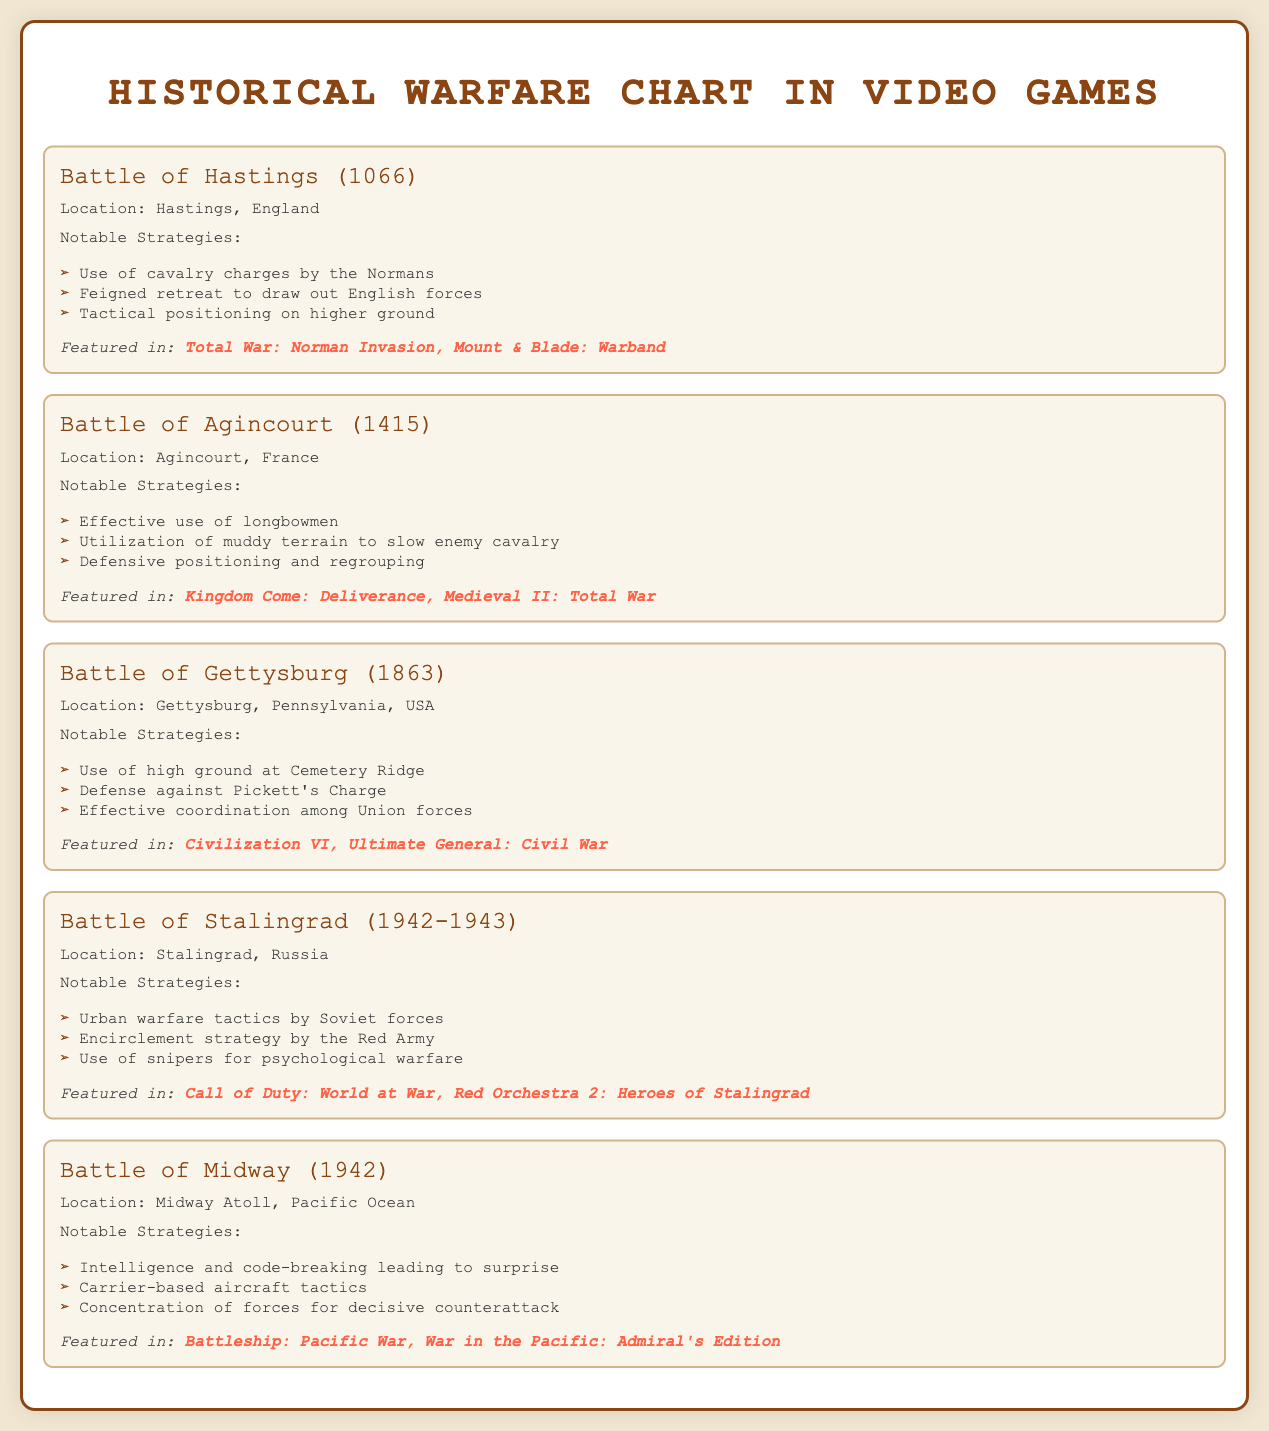What year did the Battle of Hastings occur? The document states that the Battle of Hastings occurred in 1066.
Answer: 1066 What notable strategy was used by the Normans in the Battle of Hastings? The document lists "Use of cavalry charges by the Normans" as a notable strategy.
Answer: Use of cavalry charges Where did the Battle of Gettysburg take place? According to the document, the location of the Battle of Gettysburg was Gettysburg, Pennsylvania, USA.
Answer: Gettysburg, Pennsylvania, USA Which game features the Battle of Stalingrad? The document mentions "Call of Duty: World at War" as a game featuring the Battle of Stalingrad.
Answer: Call of Duty: World at War How many notable strategies are listed for the Battle of Midway? The document includes three notable strategies for the Battle of Midway, as seen in the bullet points.
Answer: Three What battle is associated with the year 1415? The document notes that the Battle of Agincourt occurred in 1415.
Answer: Battle of Agincourt What type of warfare tactics did Soviet forces use in Stalingrad? The document states that "Urban warfare tactics" were used by Soviet forces in Stalingrad.
Answer: Urban warfare tactics What is a notable strategy employed during the Battle of Agincourt? "Effective use of longbowmen" is mentioned as a notable strategy in the document.
Answer: Effective use of longbowmen What is the document primarily about? The document is a visual summary of key battles depicted in video games.
Answer: Key battles in video games 